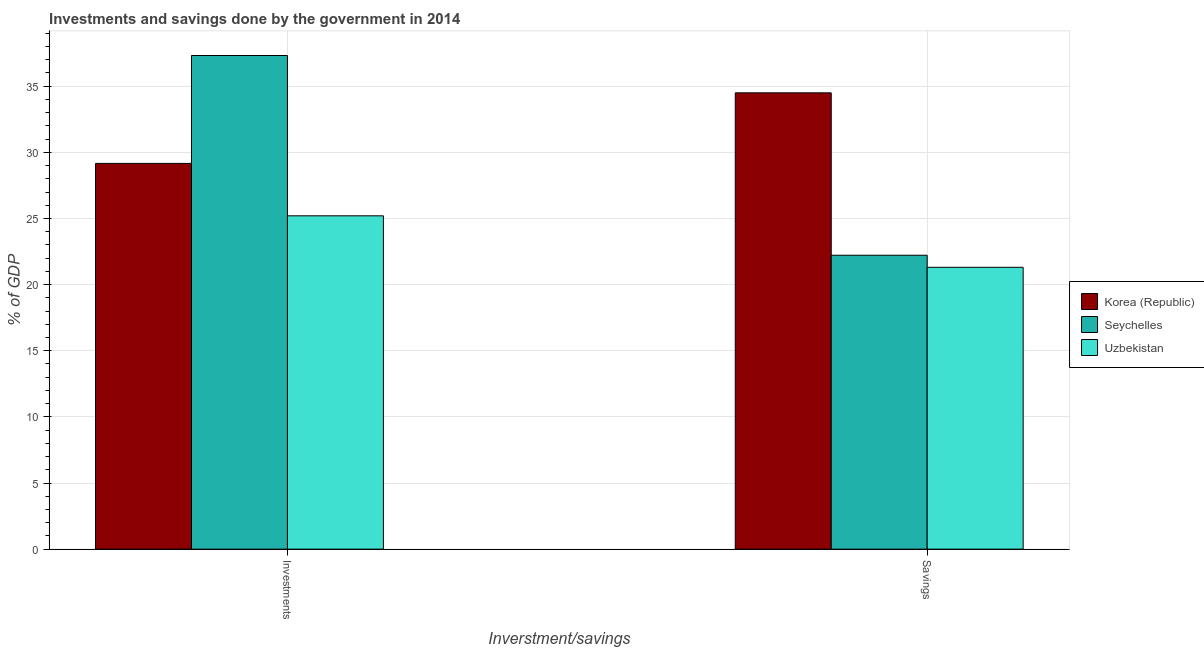How many different coloured bars are there?
Offer a terse response. 3. How many groups of bars are there?
Your answer should be very brief. 2. Are the number of bars on each tick of the X-axis equal?
Offer a very short reply. Yes. How many bars are there on the 1st tick from the right?
Keep it short and to the point. 3. What is the label of the 2nd group of bars from the left?
Provide a succinct answer. Savings. What is the investments of government in Korea (Republic)?
Offer a very short reply. 29.16. Across all countries, what is the maximum investments of government?
Your answer should be very brief. 37.32. Across all countries, what is the minimum investments of government?
Your answer should be very brief. 25.2. In which country was the investments of government maximum?
Provide a succinct answer. Seychelles. In which country was the investments of government minimum?
Your answer should be compact. Uzbekistan. What is the total investments of government in the graph?
Give a very brief answer. 91.68. What is the difference between the investments of government in Uzbekistan and that in Seychelles?
Give a very brief answer. -12.12. What is the difference between the investments of government in Seychelles and the savings of government in Uzbekistan?
Give a very brief answer. 16.01. What is the average savings of government per country?
Ensure brevity in your answer.  26.01. What is the difference between the investments of government and savings of government in Uzbekistan?
Offer a terse response. 3.89. What is the ratio of the savings of government in Uzbekistan to that in Korea (Republic)?
Provide a short and direct response. 0.62. Is the savings of government in Seychelles less than that in Uzbekistan?
Your answer should be very brief. No. What does the 3rd bar from the left in Investments represents?
Keep it short and to the point. Uzbekistan. What does the 3rd bar from the right in Savings represents?
Your answer should be compact. Korea (Republic). Are all the bars in the graph horizontal?
Keep it short and to the point. No. Does the graph contain any zero values?
Your answer should be very brief. No. Does the graph contain grids?
Keep it short and to the point. Yes. What is the title of the graph?
Your answer should be compact. Investments and savings done by the government in 2014. Does "Belgium" appear as one of the legend labels in the graph?
Your response must be concise. No. What is the label or title of the X-axis?
Provide a succinct answer. Inverstment/savings. What is the label or title of the Y-axis?
Ensure brevity in your answer.  % of GDP. What is the % of GDP of Korea (Republic) in Investments?
Offer a terse response. 29.16. What is the % of GDP in Seychelles in Investments?
Ensure brevity in your answer.  37.32. What is the % of GDP of Uzbekistan in Investments?
Your answer should be compact. 25.2. What is the % of GDP of Korea (Republic) in Savings?
Your response must be concise. 34.5. What is the % of GDP of Seychelles in Savings?
Give a very brief answer. 22.22. What is the % of GDP of Uzbekistan in Savings?
Keep it short and to the point. 21.31. Across all Inverstment/savings, what is the maximum % of GDP of Korea (Republic)?
Offer a terse response. 34.5. Across all Inverstment/savings, what is the maximum % of GDP of Seychelles?
Make the answer very short. 37.32. Across all Inverstment/savings, what is the maximum % of GDP in Uzbekistan?
Provide a short and direct response. 25.2. Across all Inverstment/savings, what is the minimum % of GDP in Korea (Republic)?
Keep it short and to the point. 29.16. Across all Inverstment/savings, what is the minimum % of GDP of Seychelles?
Keep it short and to the point. 22.22. Across all Inverstment/savings, what is the minimum % of GDP in Uzbekistan?
Offer a terse response. 21.31. What is the total % of GDP of Korea (Republic) in the graph?
Your answer should be very brief. 63.66. What is the total % of GDP of Seychelles in the graph?
Ensure brevity in your answer.  59.54. What is the total % of GDP in Uzbekistan in the graph?
Your response must be concise. 46.51. What is the difference between the % of GDP of Korea (Republic) in Investments and that in Savings?
Your answer should be compact. -5.34. What is the difference between the % of GDP of Seychelles in Investments and that in Savings?
Keep it short and to the point. 15.1. What is the difference between the % of GDP of Uzbekistan in Investments and that in Savings?
Offer a terse response. 3.89. What is the difference between the % of GDP of Korea (Republic) in Investments and the % of GDP of Seychelles in Savings?
Provide a short and direct response. 6.94. What is the difference between the % of GDP of Korea (Republic) in Investments and the % of GDP of Uzbekistan in Savings?
Provide a succinct answer. 7.85. What is the difference between the % of GDP of Seychelles in Investments and the % of GDP of Uzbekistan in Savings?
Provide a short and direct response. 16.01. What is the average % of GDP of Korea (Republic) per Inverstment/savings?
Make the answer very short. 31.83. What is the average % of GDP in Seychelles per Inverstment/savings?
Your answer should be very brief. 29.77. What is the average % of GDP of Uzbekistan per Inverstment/savings?
Your response must be concise. 23.25. What is the difference between the % of GDP in Korea (Republic) and % of GDP in Seychelles in Investments?
Keep it short and to the point. -8.16. What is the difference between the % of GDP of Korea (Republic) and % of GDP of Uzbekistan in Investments?
Provide a short and direct response. 3.96. What is the difference between the % of GDP in Seychelles and % of GDP in Uzbekistan in Investments?
Offer a very short reply. 12.12. What is the difference between the % of GDP in Korea (Republic) and % of GDP in Seychelles in Savings?
Give a very brief answer. 12.28. What is the difference between the % of GDP of Korea (Republic) and % of GDP of Uzbekistan in Savings?
Provide a short and direct response. 13.19. What is the difference between the % of GDP of Seychelles and % of GDP of Uzbekistan in Savings?
Ensure brevity in your answer.  0.91. What is the ratio of the % of GDP of Korea (Republic) in Investments to that in Savings?
Your answer should be very brief. 0.85. What is the ratio of the % of GDP in Seychelles in Investments to that in Savings?
Your answer should be compact. 1.68. What is the ratio of the % of GDP of Uzbekistan in Investments to that in Savings?
Keep it short and to the point. 1.18. What is the difference between the highest and the second highest % of GDP of Korea (Republic)?
Provide a short and direct response. 5.34. What is the difference between the highest and the second highest % of GDP of Seychelles?
Ensure brevity in your answer.  15.1. What is the difference between the highest and the second highest % of GDP of Uzbekistan?
Offer a very short reply. 3.89. What is the difference between the highest and the lowest % of GDP in Korea (Republic)?
Provide a short and direct response. 5.34. What is the difference between the highest and the lowest % of GDP in Seychelles?
Make the answer very short. 15.1. What is the difference between the highest and the lowest % of GDP of Uzbekistan?
Make the answer very short. 3.89. 